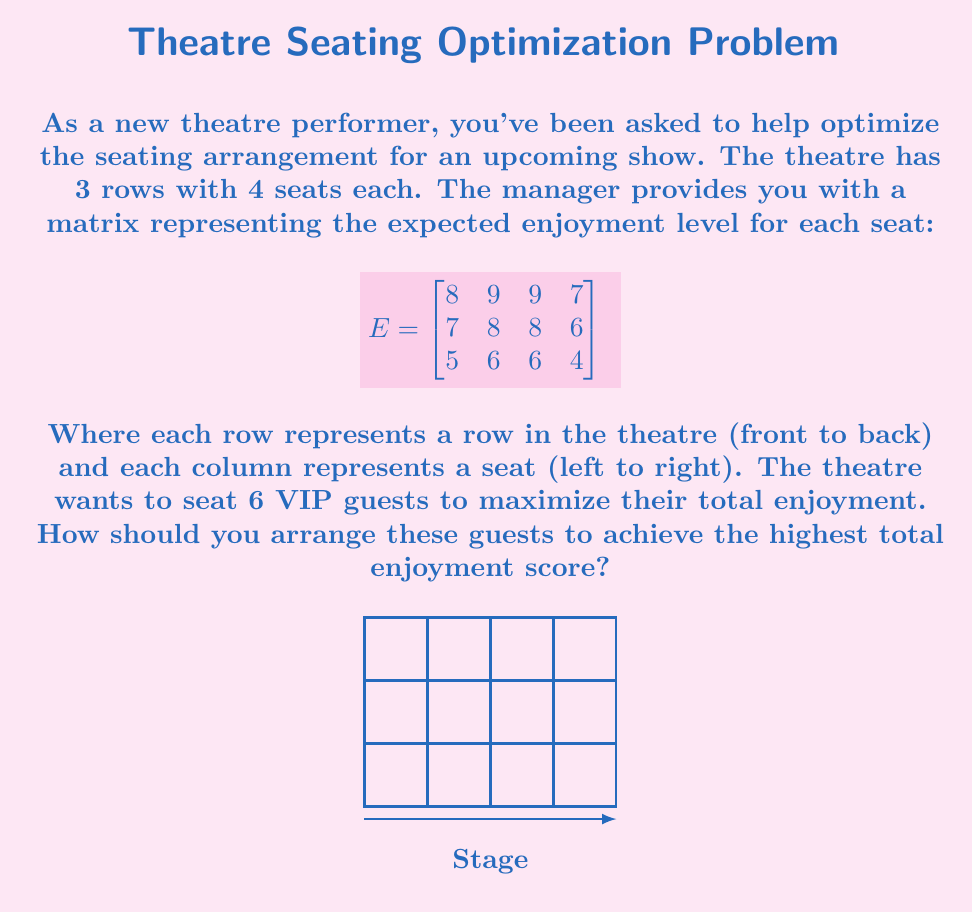Help me with this question. Let's approach this step-by-step using linear algebra:

1) First, we need to convert our problem into a linear algebra format. We can represent our seating arrangement as a matrix $X$ of the same size as $E$, where:
   $x_{ij} = 1$ if a VIP is seated in row $i$, seat $j$
   $x_{ij} = 0$ otherwise

2) Our goal is to maximize the total enjoyment, which can be represented as the sum of element-wise multiplication of $E$ and $X$:

   $$\text{Total Enjoyment} = \sum_{i=1}^3 \sum_{j=1}^4 e_{ij}x_{ij}$$

3) This is equivalent to maximizing the Frobenius inner product of $E$ and $X$:

   $$\text{Total Enjoyment} = \langle E, X \rangle_F = \text{tr}(E^T X)$$

4) Our constraints are:
   - We can only seat 6 VIP guests: $\sum_{i=1}^3 \sum_{j=1}^4 x_{ij} = 6$
   - Each seat can only be occupied by one person: $x_{ij} \in \{0,1\}$

5) This is an integer programming problem, which is NP-hard. However, for this small example, we can solve it by selecting the 6 highest values from the matrix $E$:

   $$
   E = \begin{bmatrix}
   \color{red}{8} & \color{red}{9} & \color{red}{9} & 7 \\
   7 & \color{red}{8} & \color{red}{8} & 6 \\
   5 & \color{red}{6} & 6 & 4
   \end{bmatrix}
   $$

6) The optimal seating arrangement is to place VIPs in the seats corresponding to the 6 highest values (marked in red).

7) The total enjoyment score for this arrangement is:
   $9 + 9 + 8 + 8 + 8 + 6 = 48$

Therefore, the optimal seating arrangement is to fill the entire front row, the middle two seats in the second row, and the second seat from the left in the third row.
Answer: Front row: all seats; Second row: middle two seats; Third row: second seat from left. Total enjoyment: 48. 